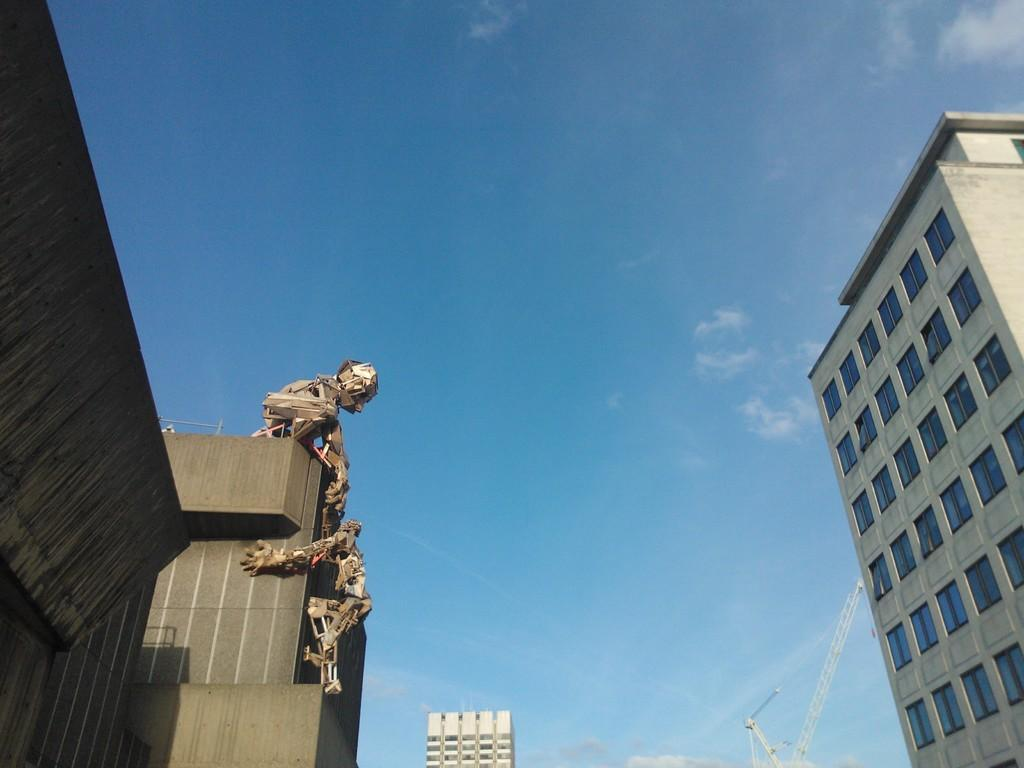What type of buildings can be seen on the right side of the image? There are skyscrapers on the right side of the image. What type of buildings can be seen on the left side of the image? There are skyscrapers on the left side of the image. Can you describe the general setting of the image? The image features a cityscape with skyscrapers on both sides. What type of quilt is being used to decorate the skyscrapers in the image? There is no quilt present in the image; it features skyscrapers without any decorative elements. Is there a birthday celebration happening in the image? There is no indication of a birthday celebration in the image. 